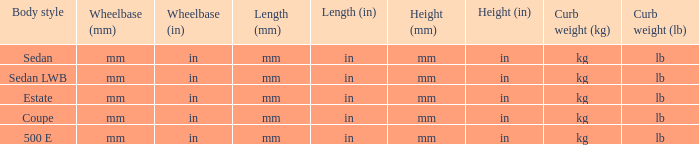For the model with a mm (in) wheelbase, mm (in) height, and 4matic feature, what is its curb weight? Kg ( lb ), kg (lb). Would you be able to parse every entry in this table? {'header': ['Body style', 'Wheelbase (mm)', 'Wheelbase (in)', 'Length (mm)', 'Length (in)', 'Height (mm)', 'Height (in)', 'Curb weight (kg)', 'Curb weight (lb)'], 'rows': [['Sedan', 'mm', 'in', 'mm', 'in', 'mm', 'in', 'kg', 'lb'], ['Sedan LWB', 'mm', 'in', 'mm', 'in', 'mm', 'in', 'kg', 'lb'], ['Estate', 'mm', 'in', 'mm', 'in', 'mm', 'in', 'kg', 'lb'], ['Coupe', 'mm', 'in', 'mm', 'in', 'mm', 'in', 'kg', 'lb'], ['500 E', 'mm', 'in', 'mm', 'in', 'mm', 'in', 'kg', 'lb']]} 